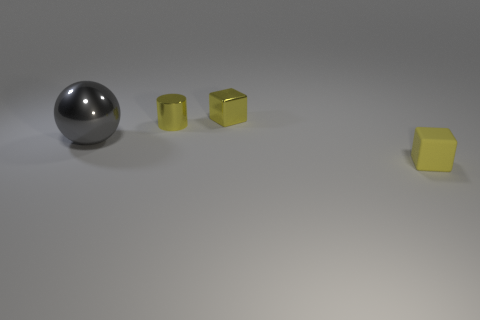Subtract 1 cylinders. How many cylinders are left? 0 Add 2 big purple rubber balls. How many objects exist? 6 Subtract all cylinders. How many objects are left? 3 Subtract all big blue balls. Subtract all large gray shiny objects. How many objects are left? 3 Add 2 metal cubes. How many metal cubes are left? 3 Add 4 large blue cylinders. How many large blue cylinders exist? 4 Subtract 0 yellow spheres. How many objects are left? 4 Subtract all cyan cubes. Subtract all cyan cylinders. How many cubes are left? 2 Subtract all purple blocks. How many cyan cylinders are left? 0 